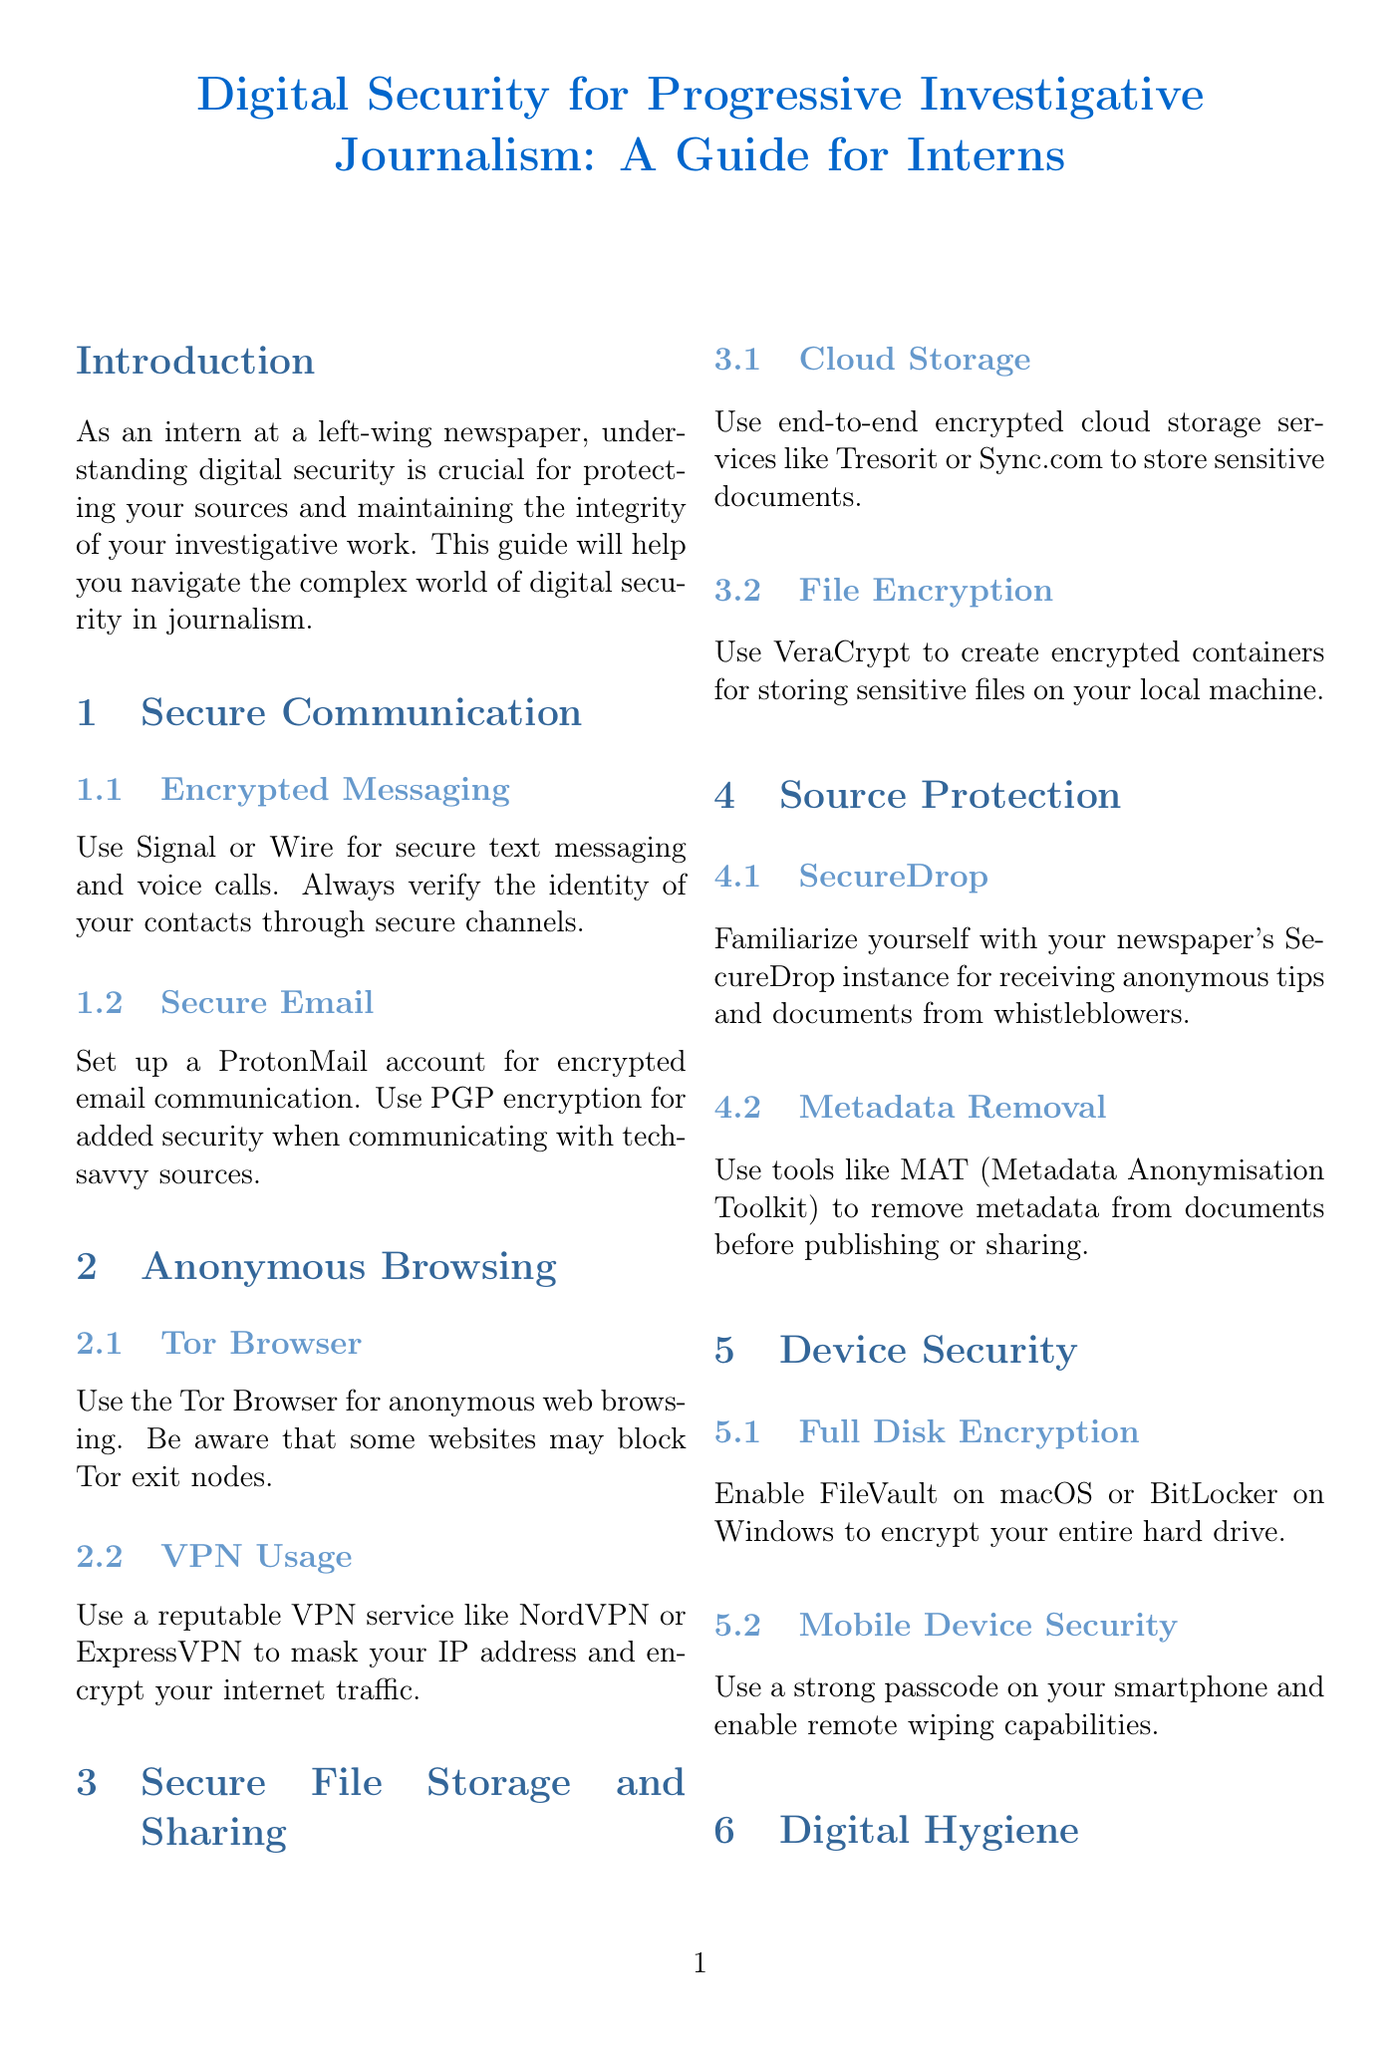What is the title of the manual? The title of the manual is stated at the beginning of the document.
Answer: Digital Security for Progressive Investigative Journalism: A Guide for Interns Which tools are recommended for encrypted messaging? The document specifies two tools for secure text messaging and voice calls.
Answer: Signal or Wire What should be used for encrypted email communication? The manual advises setting up a specific email account for secure communication.
Answer: ProtonMail What is the purpose of using a VPN? The role of a VPN is mentioned under Anonymous Browsing, detailing its benefits.
Answer: Mask your IP address and encrypt your internet traffic What is FileVault used for? The document describes the use of FileVault in relation to device security.
Answer: Encrypt your entire hard drive What does SecureDrop facilitate? The manual outlines the purpose of SecureDrop in the context of source protection.
Answer: Receiving anonymous tips and documents How should sensitive files be stored on a local machine? The guide provides a specific solution for file encryption.
Answer: Use VeraCrypt What is MAT used for? The document lists the function of MAT in relation to source protection.
Answer: Remove metadata from documents What should you prioritize when reporting on sensitive topics? The document emphasizes a specific consideration for journalists when handling sources.
Answer: The safety and well-being of your sources 